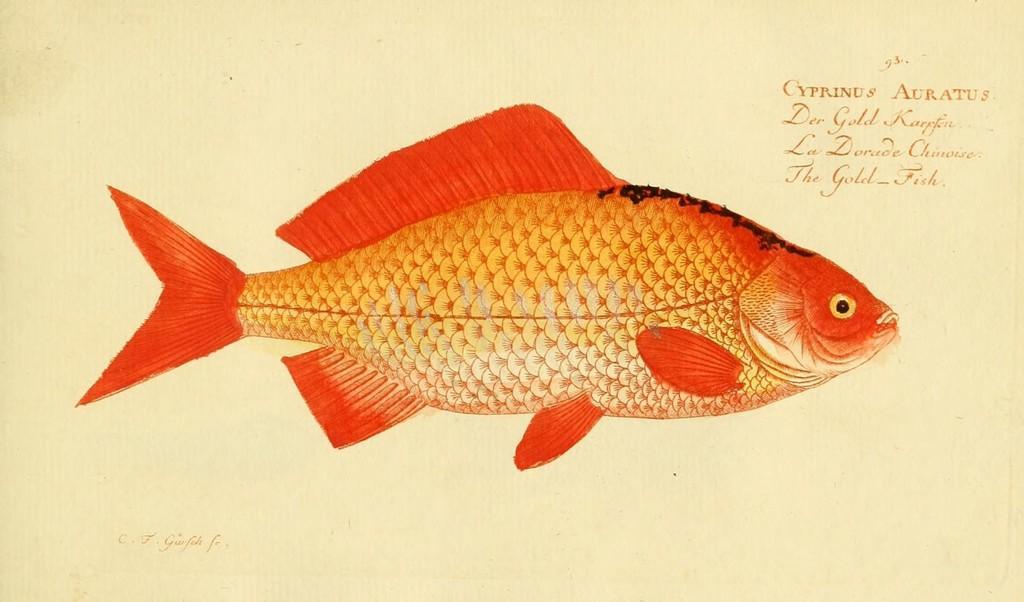How would you summarize this image in a sentence or two? In this image we can see orange color fish drawing and some text on paper. 